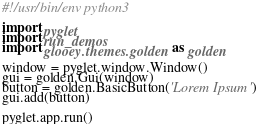Convert code to text. <code><loc_0><loc_0><loc_500><loc_500><_Python_>#!/usr/bin/env python3

import pyglet
import run_demos
import glooey.themes.golden as golden

window = pyglet.window.Window()
gui = golden.Gui(window)
button = golden.BasicButton('Lorem Ipsum')
gui.add(button)

pyglet.app.run()


</code> 